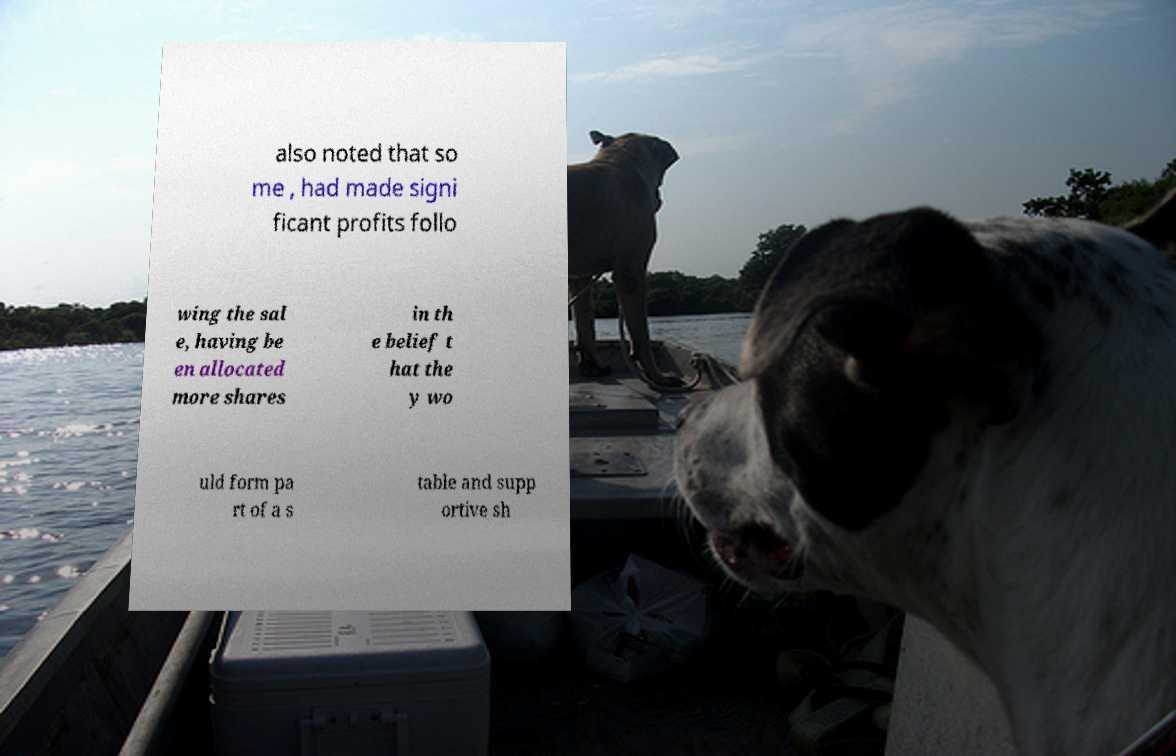Please read and relay the text visible in this image. What does it say? also noted that so me , had made signi ficant profits follo wing the sal e, having be en allocated more shares in th e belief t hat the y wo uld form pa rt of a s table and supp ortive sh 